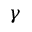<formula> <loc_0><loc_0><loc_500><loc_500>\gamma</formula> 